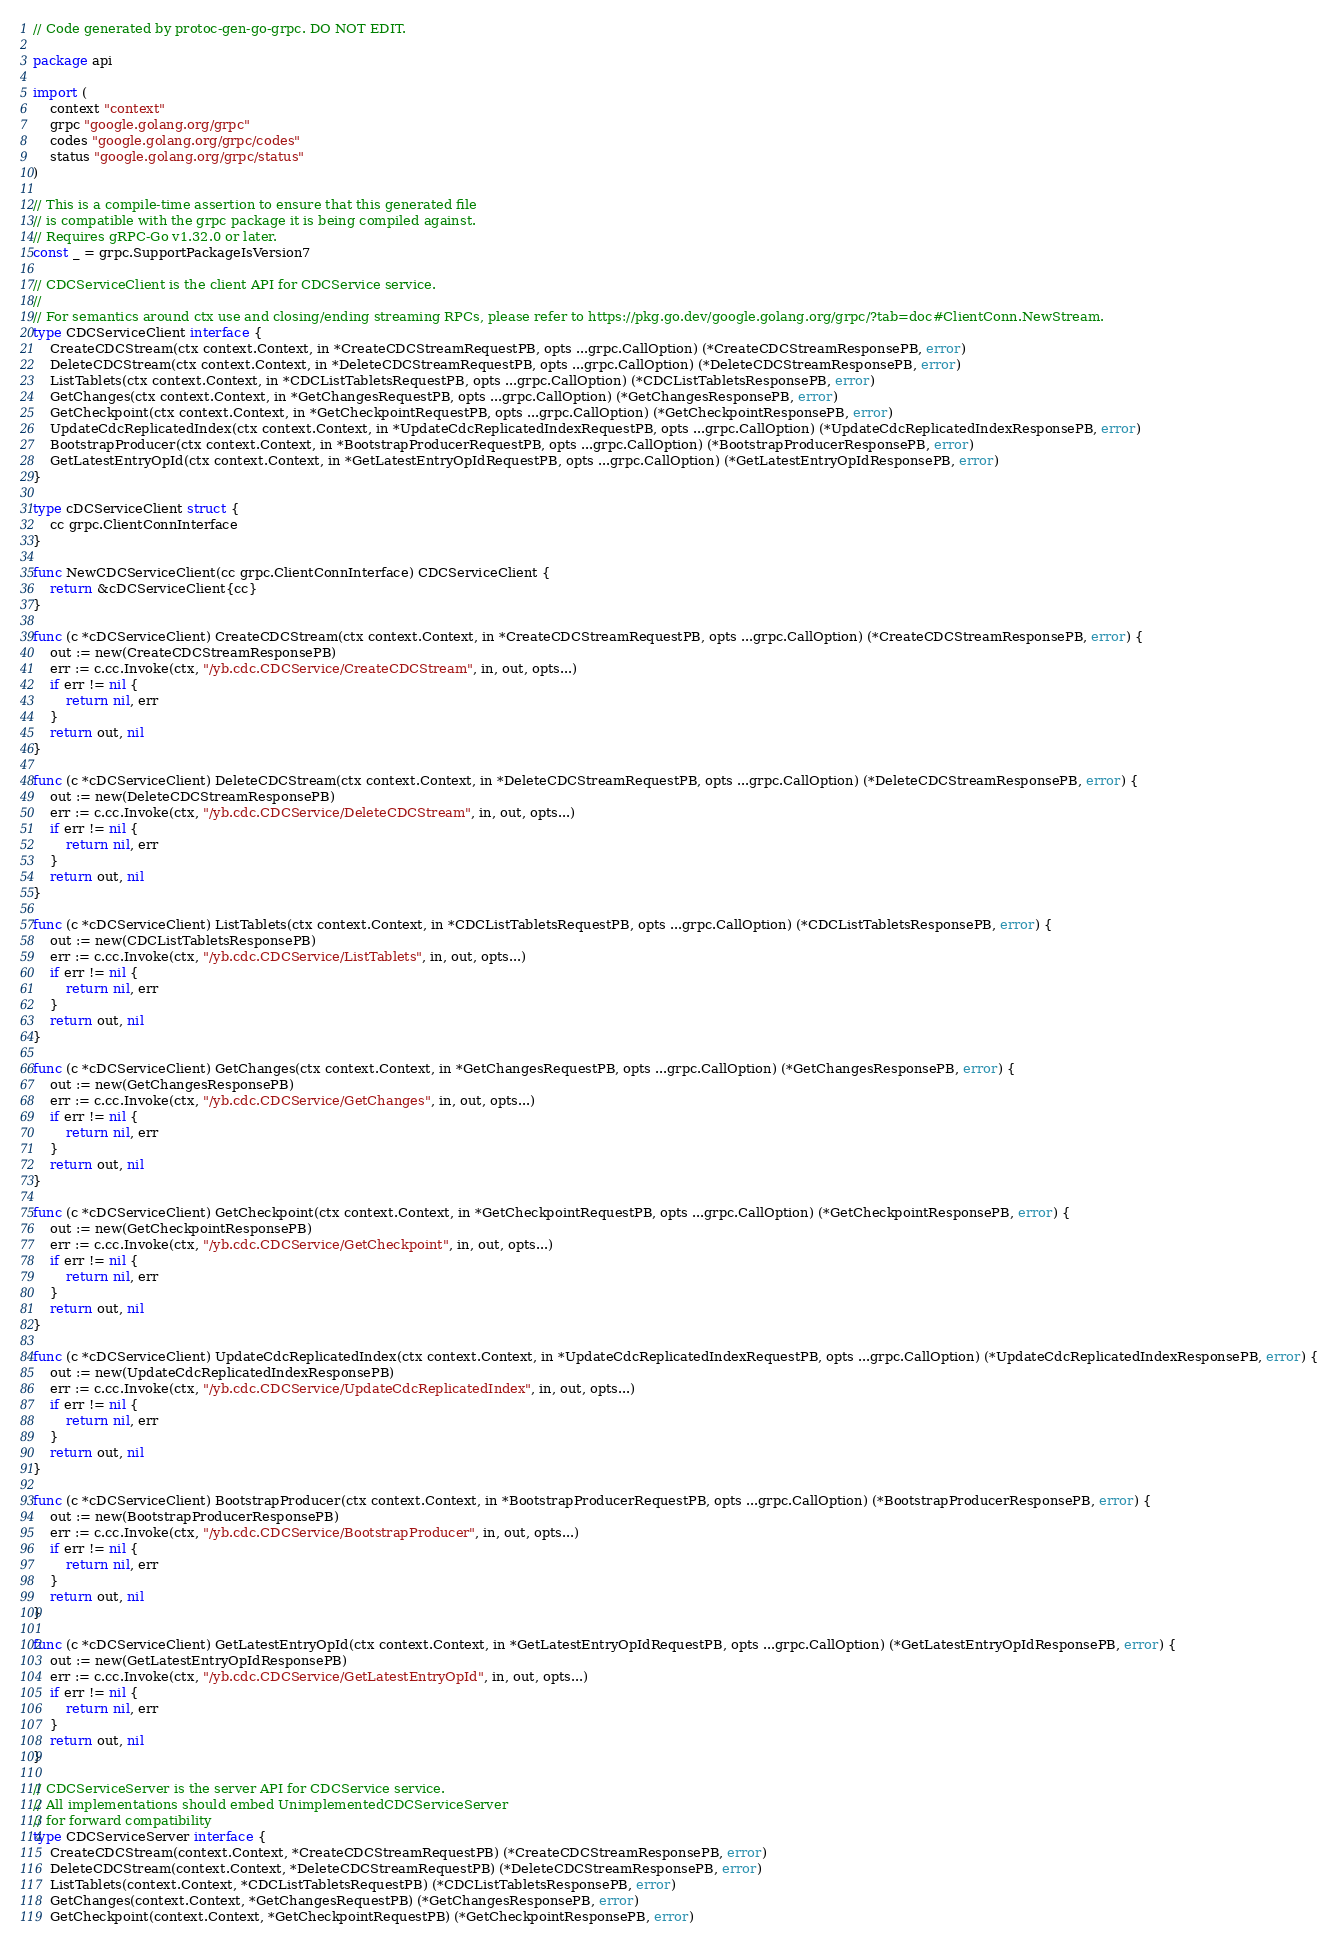Convert code to text. <code><loc_0><loc_0><loc_500><loc_500><_Go_>// Code generated by protoc-gen-go-grpc. DO NOT EDIT.

package api

import (
	context "context"
	grpc "google.golang.org/grpc"
	codes "google.golang.org/grpc/codes"
	status "google.golang.org/grpc/status"
)

// This is a compile-time assertion to ensure that this generated file
// is compatible with the grpc package it is being compiled against.
// Requires gRPC-Go v1.32.0 or later.
const _ = grpc.SupportPackageIsVersion7

// CDCServiceClient is the client API for CDCService service.
//
// For semantics around ctx use and closing/ending streaming RPCs, please refer to https://pkg.go.dev/google.golang.org/grpc/?tab=doc#ClientConn.NewStream.
type CDCServiceClient interface {
	CreateCDCStream(ctx context.Context, in *CreateCDCStreamRequestPB, opts ...grpc.CallOption) (*CreateCDCStreamResponsePB, error)
	DeleteCDCStream(ctx context.Context, in *DeleteCDCStreamRequestPB, opts ...grpc.CallOption) (*DeleteCDCStreamResponsePB, error)
	ListTablets(ctx context.Context, in *CDCListTabletsRequestPB, opts ...grpc.CallOption) (*CDCListTabletsResponsePB, error)
	GetChanges(ctx context.Context, in *GetChangesRequestPB, opts ...grpc.CallOption) (*GetChangesResponsePB, error)
	GetCheckpoint(ctx context.Context, in *GetCheckpointRequestPB, opts ...grpc.CallOption) (*GetCheckpointResponsePB, error)
	UpdateCdcReplicatedIndex(ctx context.Context, in *UpdateCdcReplicatedIndexRequestPB, opts ...grpc.CallOption) (*UpdateCdcReplicatedIndexResponsePB, error)
	BootstrapProducer(ctx context.Context, in *BootstrapProducerRequestPB, opts ...grpc.CallOption) (*BootstrapProducerResponsePB, error)
	GetLatestEntryOpId(ctx context.Context, in *GetLatestEntryOpIdRequestPB, opts ...grpc.CallOption) (*GetLatestEntryOpIdResponsePB, error)
}

type cDCServiceClient struct {
	cc grpc.ClientConnInterface
}

func NewCDCServiceClient(cc grpc.ClientConnInterface) CDCServiceClient {
	return &cDCServiceClient{cc}
}

func (c *cDCServiceClient) CreateCDCStream(ctx context.Context, in *CreateCDCStreamRequestPB, opts ...grpc.CallOption) (*CreateCDCStreamResponsePB, error) {
	out := new(CreateCDCStreamResponsePB)
	err := c.cc.Invoke(ctx, "/yb.cdc.CDCService/CreateCDCStream", in, out, opts...)
	if err != nil {
		return nil, err
	}
	return out, nil
}

func (c *cDCServiceClient) DeleteCDCStream(ctx context.Context, in *DeleteCDCStreamRequestPB, opts ...grpc.CallOption) (*DeleteCDCStreamResponsePB, error) {
	out := new(DeleteCDCStreamResponsePB)
	err := c.cc.Invoke(ctx, "/yb.cdc.CDCService/DeleteCDCStream", in, out, opts...)
	if err != nil {
		return nil, err
	}
	return out, nil
}

func (c *cDCServiceClient) ListTablets(ctx context.Context, in *CDCListTabletsRequestPB, opts ...grpc.CallOption) (*CDCListTabletsResponsePB, error) {
	out := new(CDCListTabletsResponsePB)
	err := c.cc.Invoke(ctx, "/yb.cdc.CDCService/ListTablets", in, out, opts...)
	if err != nil {
		return nil, err
	}
	return out, nil
}

func (c *cDCServiceClient) GetChanges(ctx context.Context, in *GetChangesRequestPB, opts ...grpc.CallOption) (*GetChangesResponsePB, error) {
	out := new(GetChangesResponsePB)
	err := c.cc.Invoke(ctx, "/yb.cdc.CDCService/GetChanges", in, out, opts...)
	if err != nil {
		return nil, err
	}
	return out, nil
}

func (c *cDCServiceClient) GetCheckpoint(ctx context.Context, in *GetCheckpointRequestPB, opts ...grpc.CallOption) (*GetCheckpointResponsePB, error) {
	out := new(GetCheckpointResponsePB)
	err := c.cc.Invoke(ctx, "/yb.cdc.CDCService/GetCheckpoint", in, out, opts...)
	if err != nil {
		return nil, err
	}
	return out, nil
}

func (c *cDCServiceClient) UpdateCdcReplicatedIndex(ctx context.Context, in *UpdateCdcReplicatedIndexRequestPB, opts ...grpc.CallOption) (*UpdateCdcReplicatedIndexResponsePB, error) {
	out := new(UpdateCdcReplicatedIndexResponsePB)
	err := c.cc.Invoke(ctx, "/yb.cdc.CDCService/UpdateCdcReplicatedIndex", in, out, opts...)
	if err != nil {
		return nil, err
	}
	return out, nil
}

func (c *cDCServiceClient) BootstrapProducer(ctx context.Context, in *BootstrapProducerRequestPB, opts ...grpc.CallOption) (*BootstrapProducerResponsePB, error) {
	out := new(BootstrapProducerResponsePB)
	err := c.cc.Invoke(ctx, "/yb.cdc.CDCService/BootstrapProducer", in, out, opts...)
	if err != nil {
		return nil, err
	}
	return out, nil
}

func (c *cDCServiceClient) GetLatestEntryOpId(ctx context.Context, in *GetLatestEntryOpIdRequestPB, opts ...grpc.CallOption) (*GetLatestEntryOpIdResponsePB, error) {
	out := new(GetLatestEntryOpIdResponsePB)
	err := c.cc.Invoke(ctx, "/yb.cdc.CDCService/GetLatestEntryOpId", in, out, opts...)
	if err != nil {
		return nil, err
	}
	return out, nil
}

// CDCServiceServer is the server API for CDCService service.
// All implementations should embed UnimplementedCDCServiceServer
// for forward compatibility
type CDCServiceServer interface {
	CreateCDCStream(context.Context, *CreateCDCStreamRequestPB) (*CreateCDCStreamResponsePB, error)
	DeleteCDCStream(context.Context, *DeleteCDCStreamRequestPB) (*DeleteCDCStreamResponsePB, error)
	ListTablets(context.Context, *CDCListTabletsRequestPB) (*CDCListTabletsResponsePB, error)
	GetChanges(context.Context, *GetChangesRequestPB) (*GetChangesResponsePB, error)
	GetCheckpoint(context.Context, *GetCheckpointRequestPB) (*GetCheckpointResponsePB, error)</code> 